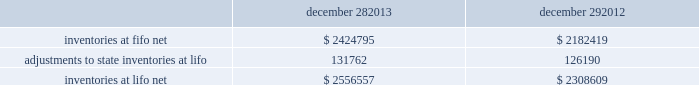Advance auto parts , inc .
And subsidiaries notes to the consolidated financial statements december 28 , 2013 , december 29 , 2012 and december 31 , 2011 ( in thousands , except per share data ) in july 2012 , the fasb issued asu no .
2012-02 201cintangible-goodwill and other 2013 testing indefinite-lived intangible assets for impairment . 201d asu 2012-02 modifies the requirement to test intangible assets that are not subject to amortization based on events or changes in circumstances that might indicate that the asset is impaired now requiring the test only if it is more likely than not that the asset is impaired .
Furthermore , asu 2012-02 provides entities the option of performing a qualitative assessment to determine if it is more likely than not that the fair value of an intangible asset is less than the carrying amount as a basis for determining whether it is necessary to perform a quantitative impairment test .
Asu 2012-02 is effective for fiscal years beginning after september 15 , 2012 and early adoption is permitted .
The adoption of asu 2012-02 had no impact on the company 2019s consolidated financial condition , results of operations or cash flows .
Inventories , net : merchandise inventory the company used the lifo method of accounting for approximately 95% ( 95 % ) of inventories at both december 28 , 2013 and december 29 , 2012 .
Under lifo , the company 2019s cost of sales reflects the costs of the most recently purchased inventories , while the inventory carrying balance represents the costs for inventories purchased in fiscal 2013 and prior years .
The company recorded a reduction to cost of sales of $ 5572 and $ 24087 in fiscal 2013 and fiscal 2012 , respectively .
The company 2019s overall costs to acquire inventory for the same or similar products have generally decreased historically as the company has been able to leverage its continued growth , execution of merchandise strategies and realization of supply chain efficiencies .
In fiscal 2011 , the company recorded an increase to cost of sales of $ 24708 due to an increase in supply chain costs and inflationary pressures affecting certain product categories .
Product cores the remaining inventories are comprised of product cores , the non-consumable portion of certain parts and batteries , which are valued under the first-in , first-out ( 201cfifo 201d ) method .
Product cores are included as part of the company 2019s merchandise costs and are either passed on to the customer or returned to the vendor .
Because product cores are not subject to frequent cost changes like the company 2019s other merchandise inventory , there is no material difference when applying either the lifo or fifo valuation method .
Inventory overhead costs purchasing and warehousing costs included in inventory as of december 28 , 2013 and december 29 , 2012 , were $ 161519 and $ 134258 , respectively .
Inventory balance and inventory reserves inventory balances at the end of fiscal 2013 and 2012 were as follows : december 28 , december 29 .
Inventory quantities are tracked through a perpetual inventory system .
The company completes physical inventories and other targeted inventory counts in its store locations to ensure the accuracy of the perpetual inventory quantities of both merchandise and core inventory in these locations .
In its distribution centers and pdq aes , the company uses a cycle counting program to ensure the accuracy of the perpetual inventory quantities of both merchandise and product core inventory .
Reserves for estimated shrink are established based on the results of physical inventories conducted by the company with the assistance of an independent third party in substantially all of the company 2019s stores over the course of the year , other targeted inventory counts in its stores , results from recent cycle counts in its distribution facilities and historical and current loss trends. .
What was the percentage increase of inventories at lifo net from the beginning of 2012 to the end of 2013? 
Rationale: to find the percentage increase of inventories at lifo net , one must take the inventories for 2013 and subtract it from the inventories from 2012 . then take the answer and divide it by the inventories for 2012
Computations: ((2556557 * 2182419) / 2182419)
Answer: 2556557.0. 